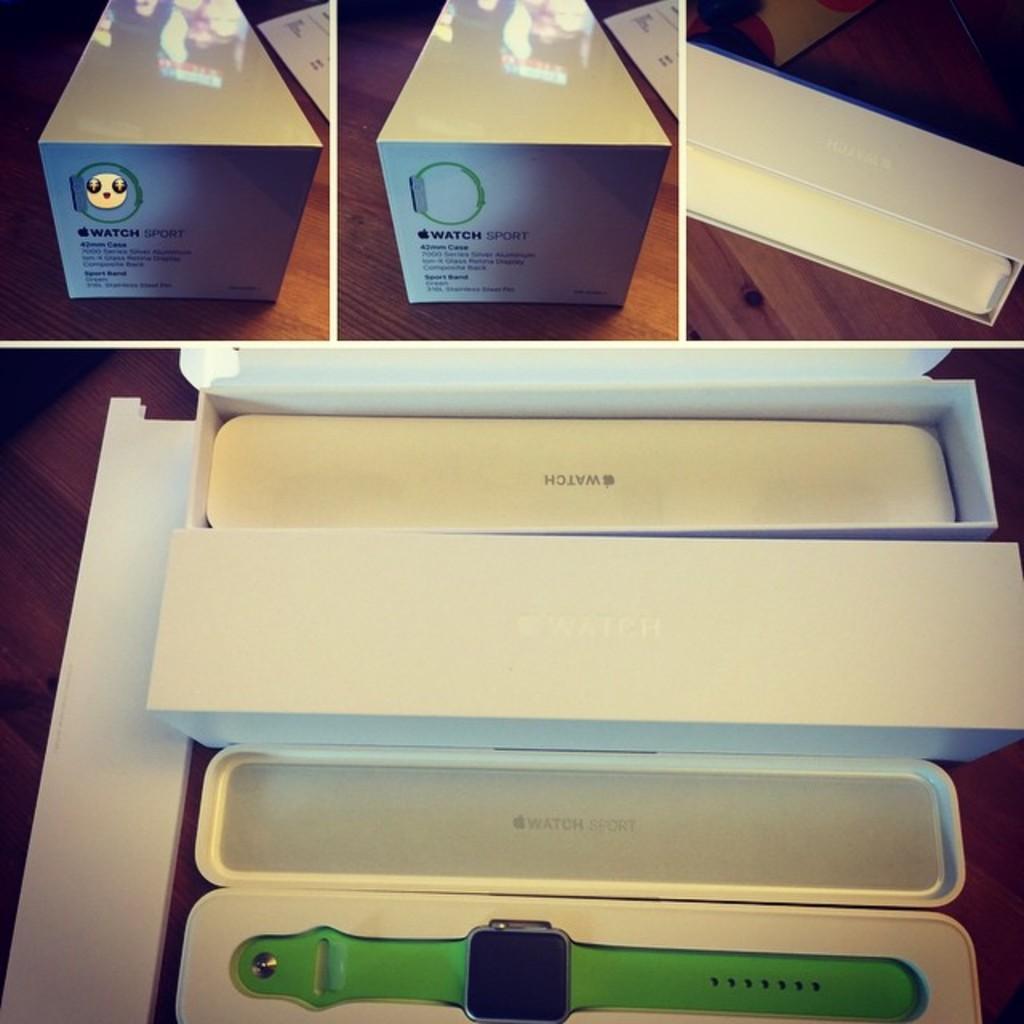Could you give a brief overview of what you see in this image? It is a collage picture. In the center of the image we can see tables. On the tables, we can see the papers, square and rectangle shape boxes and a few other objects. In one of the boxes, we can see one watch, which is in green and black color. And we can see some text on the boxes. 